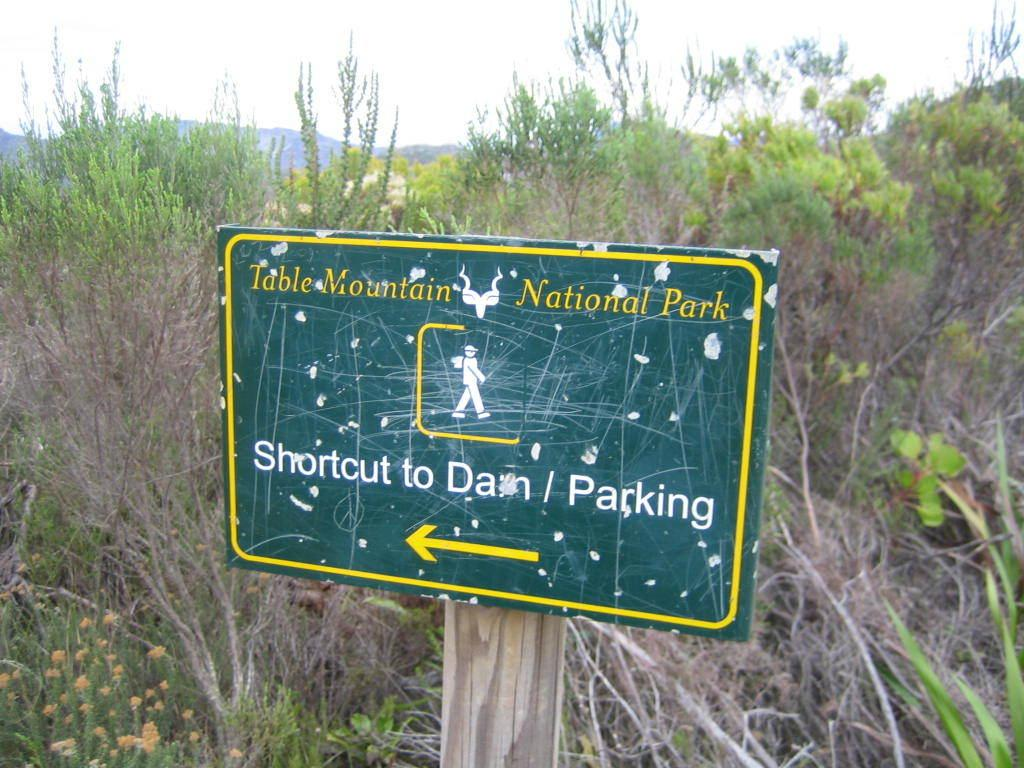What is the main object at the center of the image? There is a green board at the center of the image. What color are the borders of the green board? The green board has yellow borders. What is located at the bottom of the green board? There is a yellow arrow at the bottom of the green board. What can be seen behind the green board? There are plants visible behind the green board. What is visible at the top of the image? The sky is visible at the top of the image. What position does the alley hold in the image? There is no alley present in the image. What type of border is visible at the top of the green board? The green board has yellow borders, but there is no border visible at the top of the green board. 